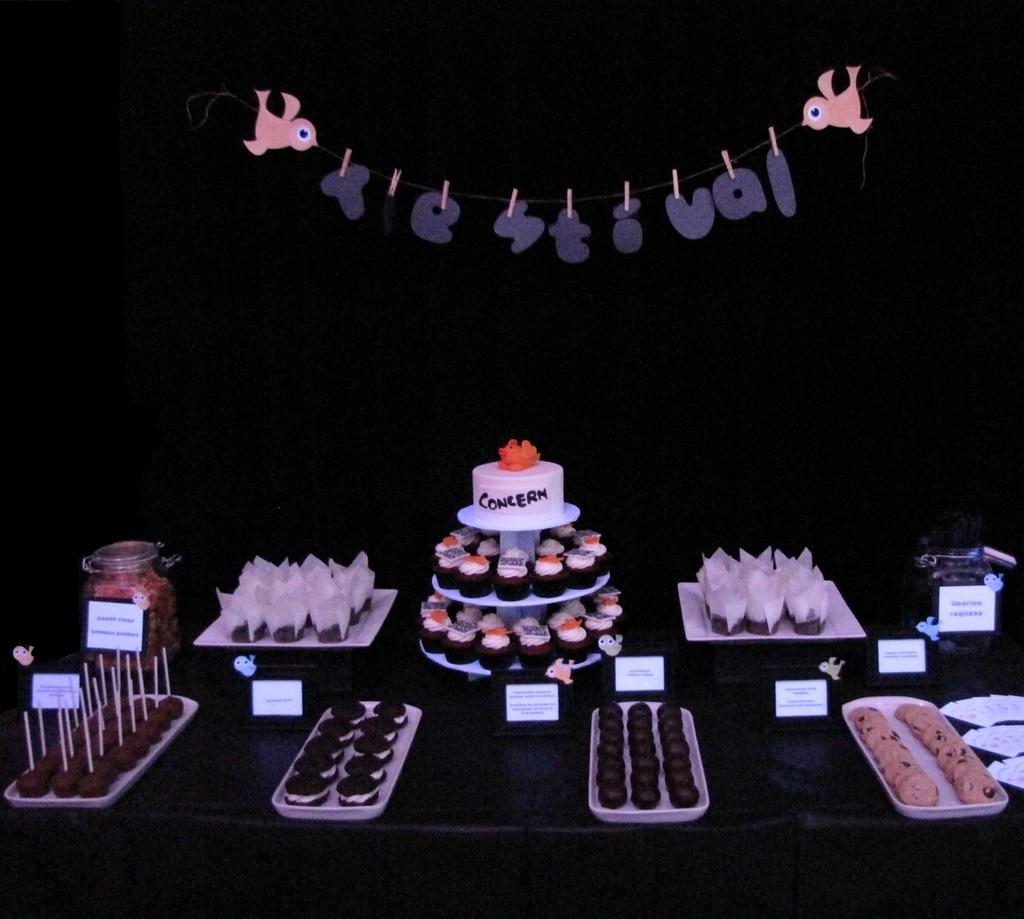What types of food items can be seen in the image? There are cupcakes in the image. Can you describe any other food items visible in the image? The facts provided only mention cupcakes, so there is no information about other food items. What type of birds can be seen flying over the cupcakes in the image? There are no birds present in the image; it only features cupcakes. How does the muscle of the cupcakes contribute to their structural integrity in the image? Cupcakes do not have muscles, as they are baked goods and not living organisms. 